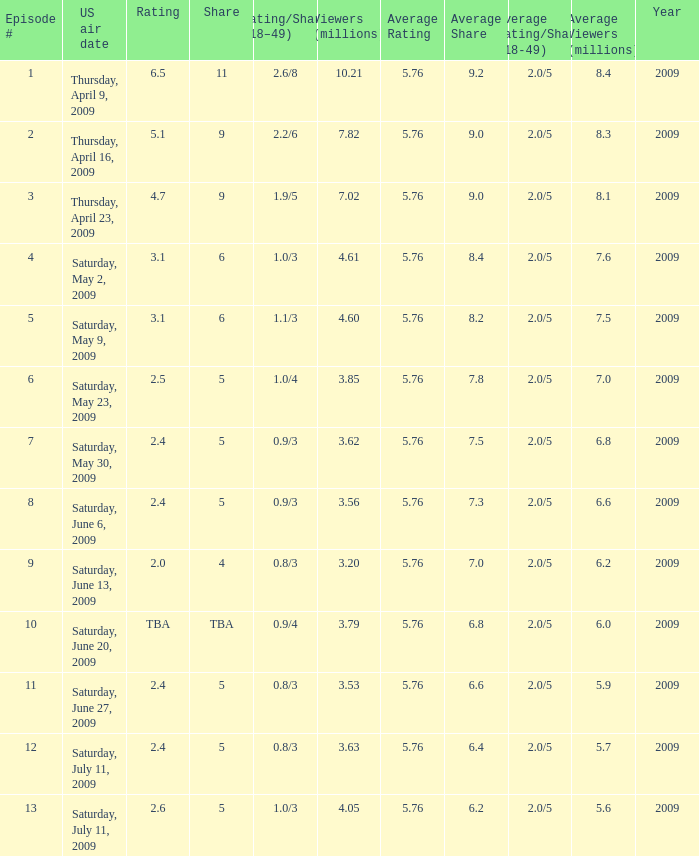What is the lowest number of million viewers for an episode before episode 5 with a rating/share of 1.1/3? None. 